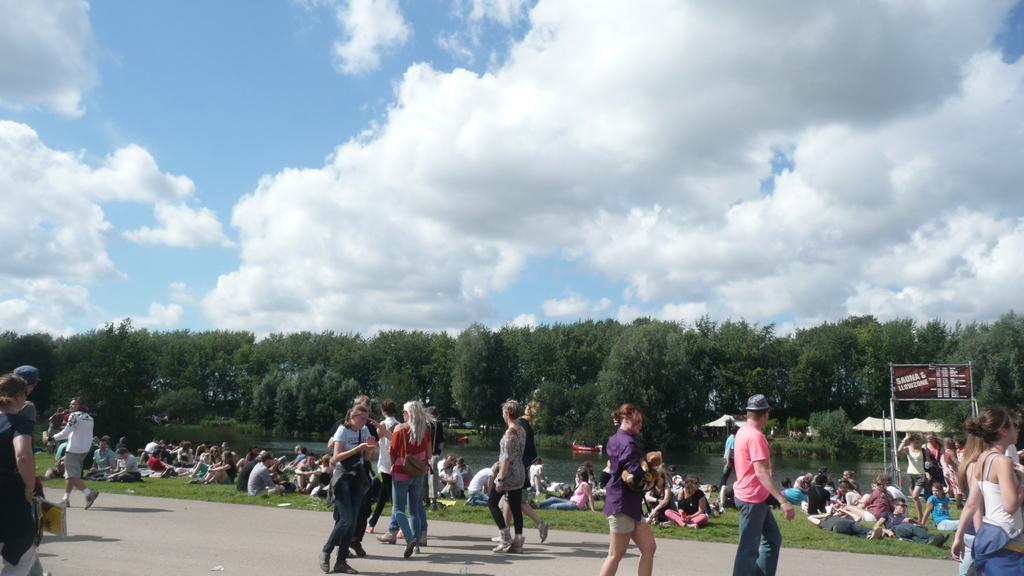Describe this image in one or two sentences. In this picture we can observe some people walking on the road and some of them were sitting on the ground. We can observe a lake here there are men and women in this picture. In the background there are trees and sky with some clouds. 